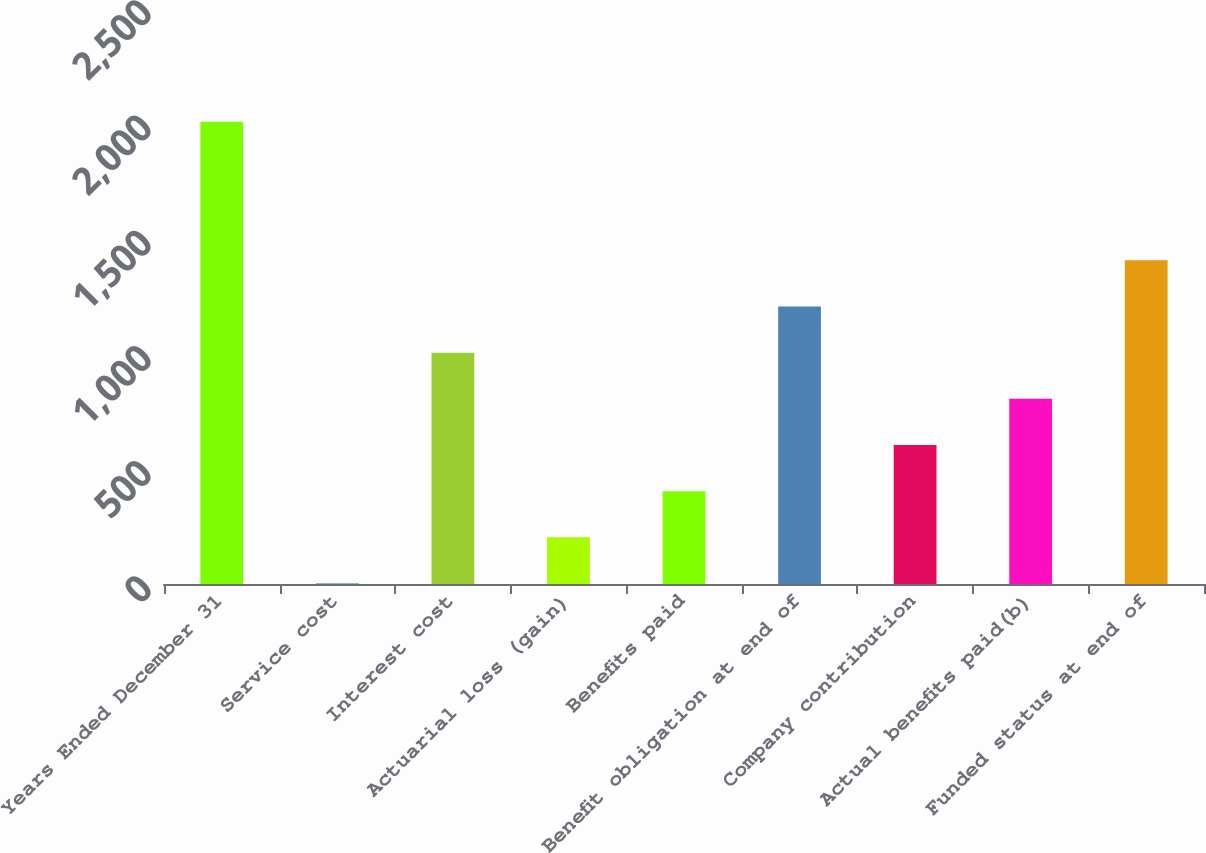Convert chart to OTSL. <chart><loc_0><loc_0><loc_500><loc_500><bar_chart><fcel>Years Ended December 31<fcel>Service cost<fcel>Interest cost<fcel>Actuarial loss (gain)<fcel>Benefits paid<fcel>Benefit obligation at end of<fcel>Company contribution<fcel>Actual benefits paid(b)<fcel>Funded status at end of<nl><fcel>2006<fcel>2<fcel>1004<fcel>202.4<fcel>402.8<fcel>1204.4<fcel>603.2<fcel>803.6<fcel>1404.8<nl></chart> 